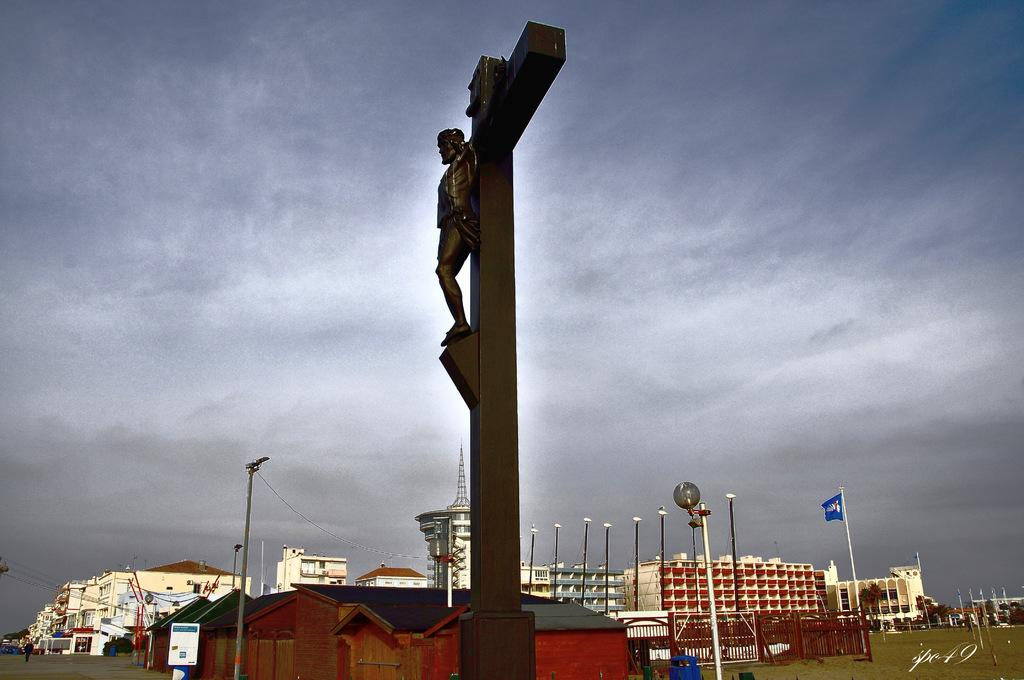What is the main subject of the image? There is a sculpture in the image. What else can be seen in the image besides the sculpture? There are buildings, a board, poles, trees, and a flag visible in the image. Can you describe the background of the image? The sky is visible in the background of the image. How many kittens are playing with the flag in the image? There are no kittens present in the image, so it is not possible to determine how many might be playing with the flag. 